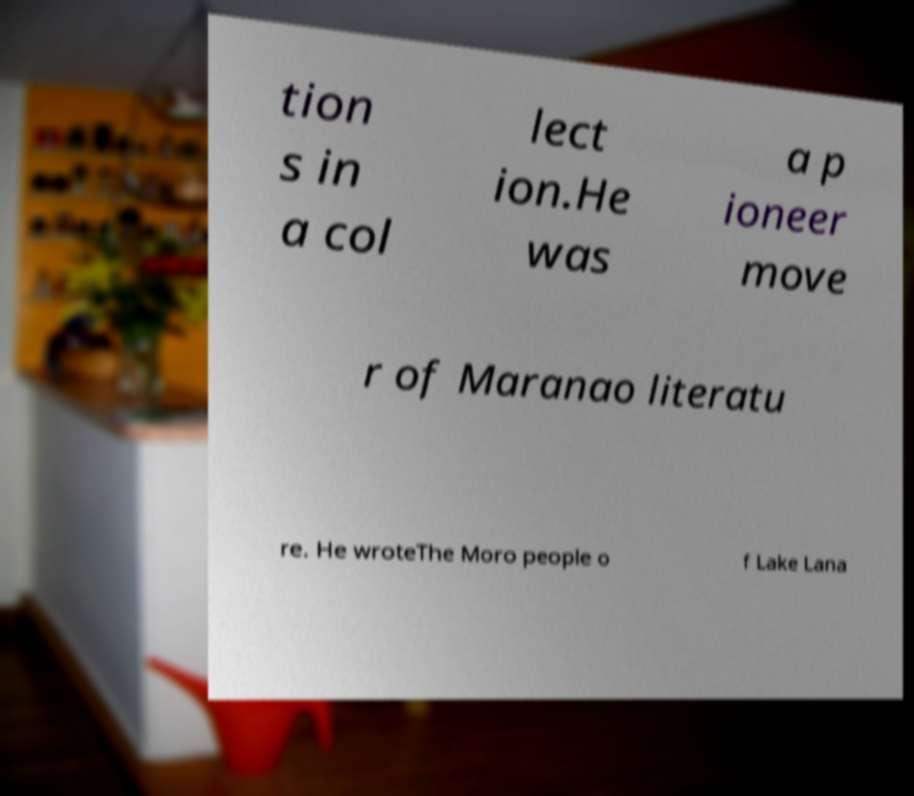For documentation purposes, I need the text within this image transcribed. Could you provide that? tion s in a col lect ion.He was a p ioneer move r of Maranao literatu re. He wroteThe Moro people o f Lake Lana 